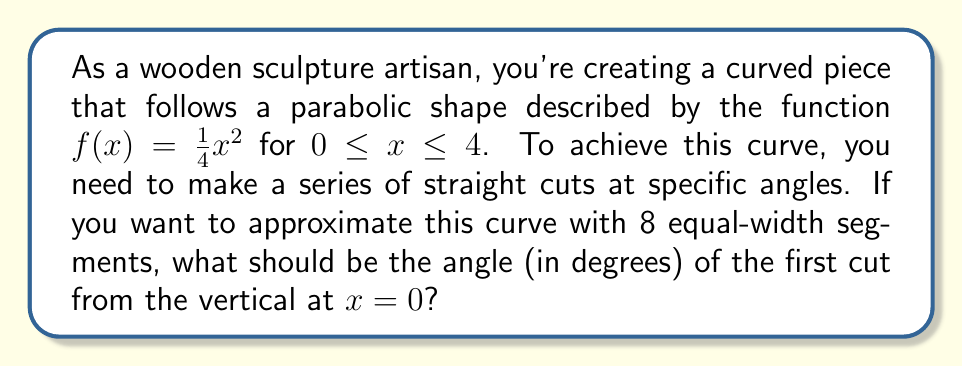Give your solution to this math problem. Let's approach this step-by-step:

1) The parabola is described by $f(x) = \frac{1}{4}x^2$ for $0 \leq x \leq 4$.

2) We need to divide the interval $[0, 4]$ into 8 equal segments. Each segment will have a width of $\frac{4}{8} = 0.5$.

3) To find the angle of the first cut, we need to calculate the slope of the tangent line at $x = 0.25$ (the midpoint of the first segment).

4) The derivative of $f(x)$ is $f'(x) = \frac{1}{2}x$.

5) At $x = 0.25$, the slope is:
   $f'(0.25) = \frac{1}{2}(0.25) = 0.125$

6) The angle $\theta$ between this tangent line and the vertical is given by:
   $\theta = \arctan(0.125)$

7) Converting this to degrees:
   $\theta = \arctan(0.125) \cdot \frac{180}{\pi} \approx 7.125°$

[asy]
import graph;
size(200,200);
real f(real x) {return x^2/4;}
draw(graph(f,0,4));
draw((0,0)--(4,4),dashed);
draw((0,0)--(0.5,f(0.5)));
draw((0,0)--(0.25,2),red);
label("$\theta$",(0.05,0.2),E);
[/asy]
Answer: $7.125°$ 